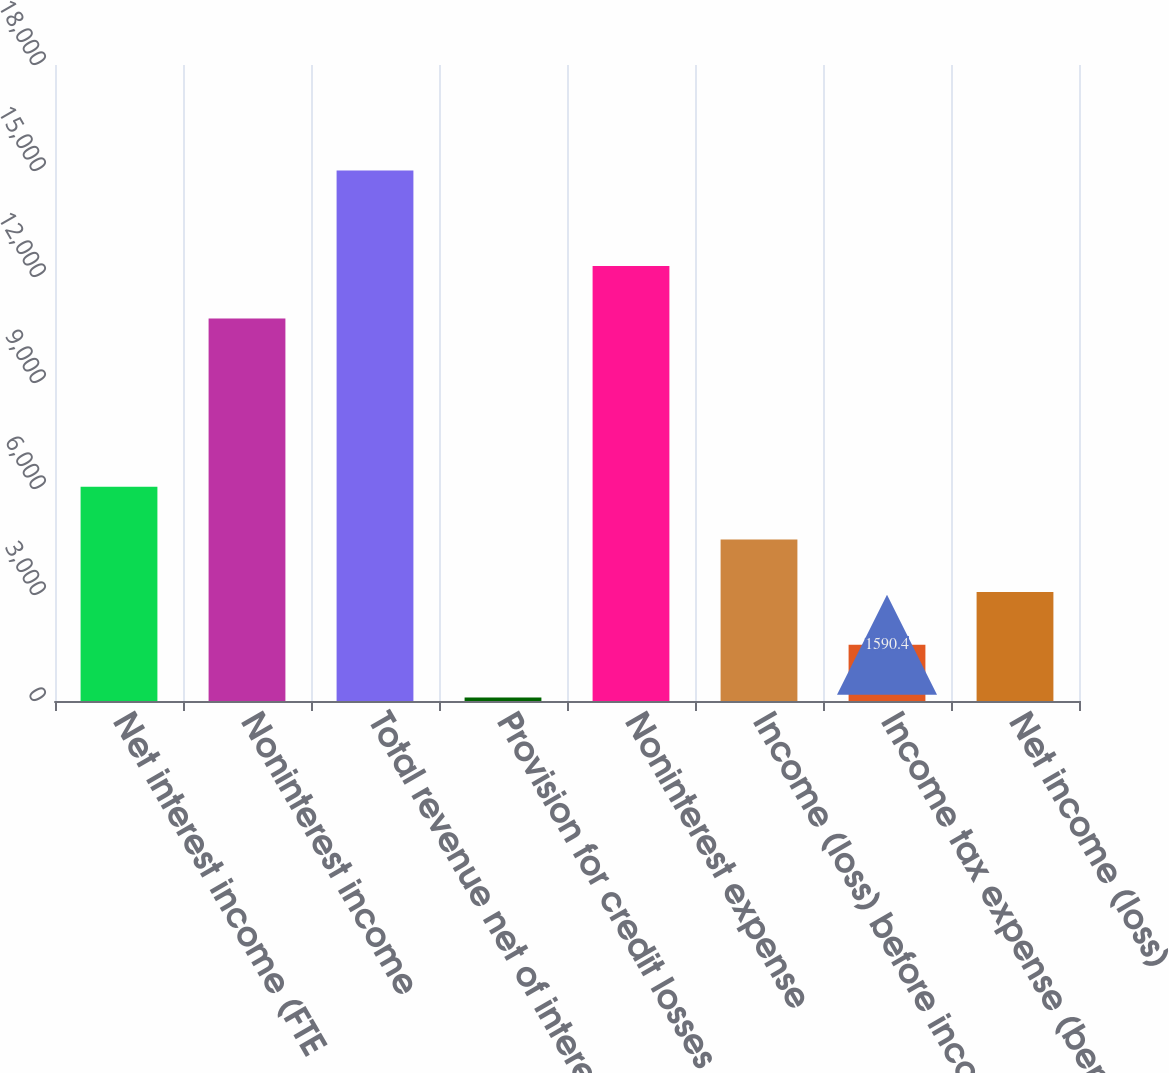Convert chart to OTSL. <chart><loc_0><loc_0><loc_500><loc_500><bar_chart><fcel>Net interest income (FTE<fcel>Noninterest income<fcel>Total revenue net of interest<fcel>Provision for credit losses<fcel>Noninterest expense<fcel>Income (loss) before income<fcel>Income tax expense (benefit)<fcel>Net income (loss)<nl><fcel>6064.6<fcel>10822<fcel>15013<fcel>99<fcel>12313.4<fcel>4573.2<fcel>1590.4<fcel>3081.8<nl></chart> 